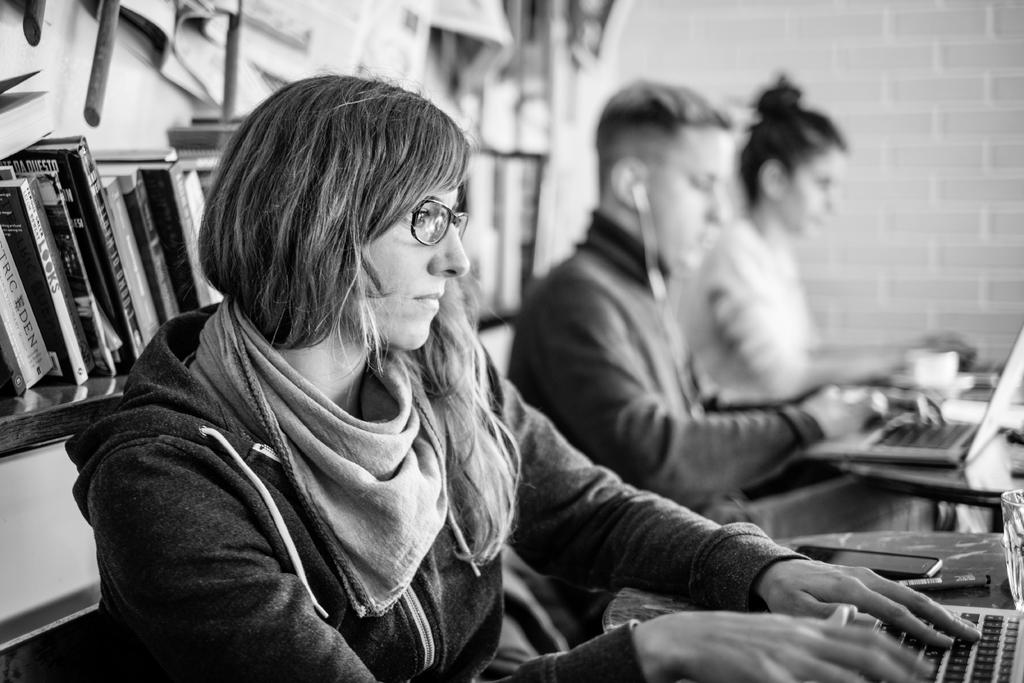<image>
Give a short and clear explanation of the subsequent image. the word questo is on a book behind the lady 